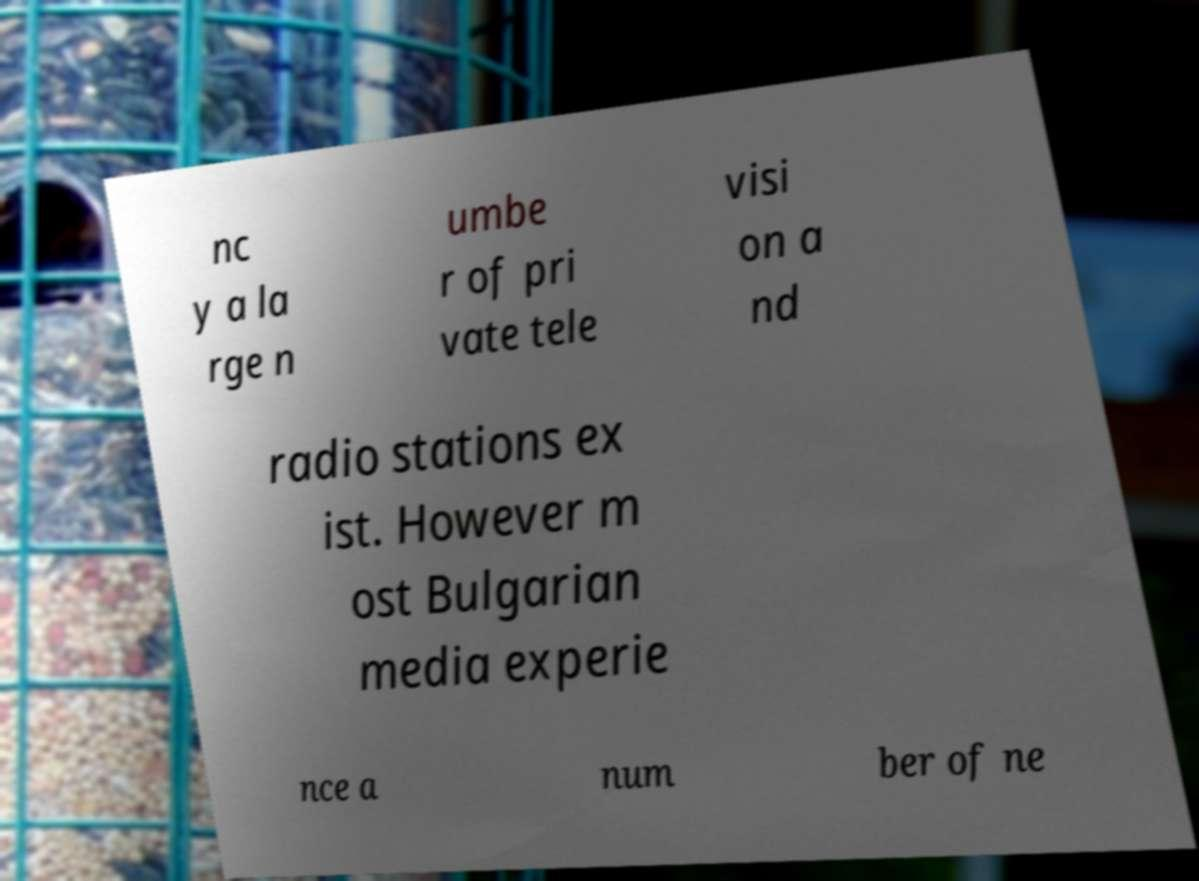Can you read and provide the text displayed in the image?This photo seems to have some interesting text. Can you extract and type it out for me? nc y a la rge n umbe r of pri vate tele visi on a nd radio stations ex ist. However m ost Bulgarian media experie nce a num ber of ne 